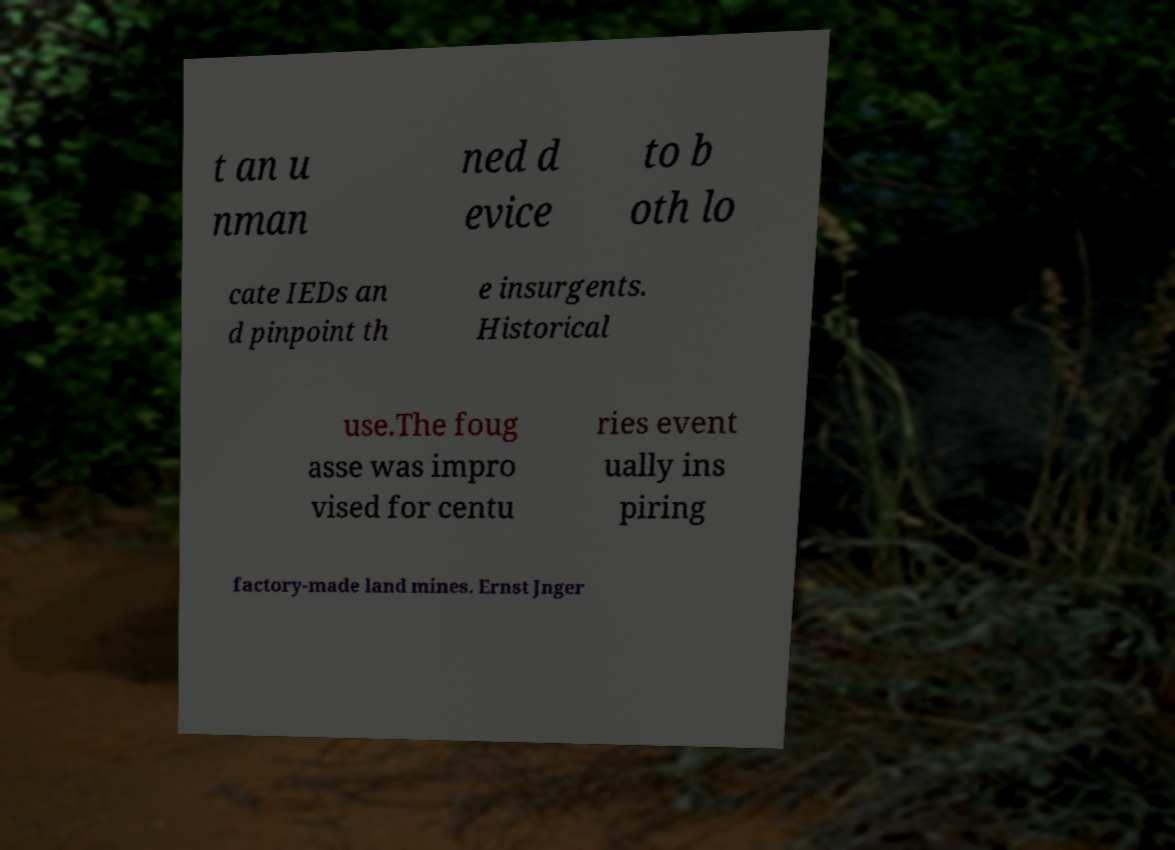Could you extract and type out the text from this image? t an u nman ned d evice to b oth lo cate IEDs an d pinpoint th e insurgents. Historical use.The foug asse was impro vised for centu ries event ually ins piring factory-made land mines. Ernst Jnger 